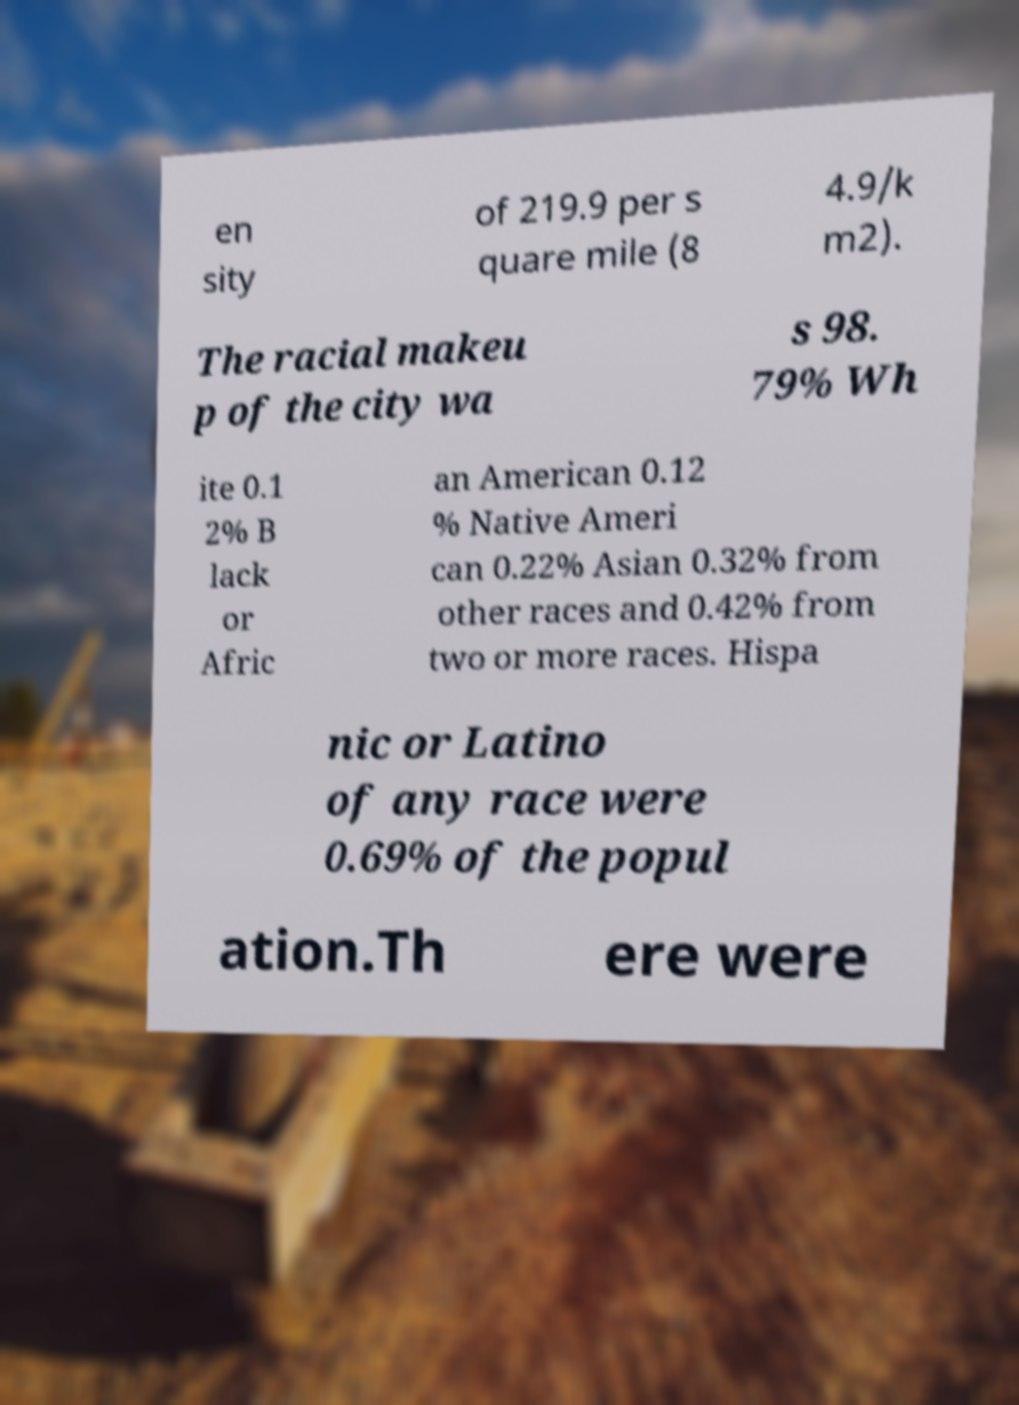Please read and relay the text visible in this image. What does it say? en sity of 219.9 per s quare mile (8 4.9/k m2). The racial makeu p of the city wa s 98. 79% Wh ite 0.1 2% B lack or Afric an American 0.12 % Native Ameri can 0.22% Asian 0.32% from other races and 0.42% from two or more races. Hispa nic or Latino of any race were 0.69% of the popul ation.Th ere were 